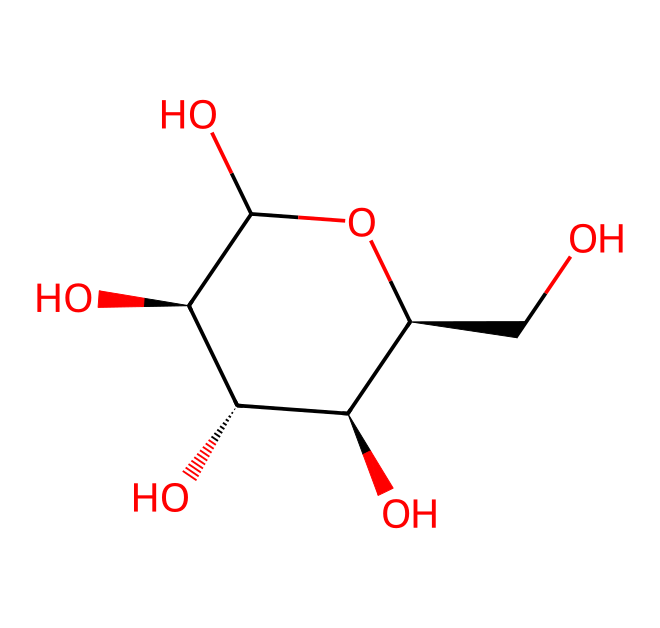What is the molecular formula of cellulose represented by this SMILES? To deduce the molecular formula from the SMILES, we count the number of each type of atom present. In the given structure, we identify 6 carbon (C), 10 hydrogen (H), and 5 oxygen (O) atoms, leading to the formula C6H10O5.
Answer: C6H10O5 How many chiral centers are present in the cellulose structure? A chiral center is identified by the presence of a carbon atom bound to four different groups. In this structure, there are 4 carbon atoms that meet this criterion, indicating 4 chiral centers.
Answer: 4 What type of bonds are predominantly found in cellulose's structure? Cellulose is a polysaccharide composed largely of glycosidic bonds, which are formed through dehydration reactions between hydroxyl groups of glucose units. Additionally, we find many hydrogen bonds contributing to its structural stability.
Answer: glycosidic Does cellulose have a reducing sugar property? Reducing sugars contain a free aldehyde or ketone group that can donate electrons. In cellulose, the structure lacks a free terminal group due to its polymeric nature, thus it does not have reducing sugar property.
Answer: no What is the primary function of cellulose in plants? Cellulose serves as a structural component, forming the cell walls of plants, providing rigidity and strength to maintain the plant’s structure.
Answer: structural support 